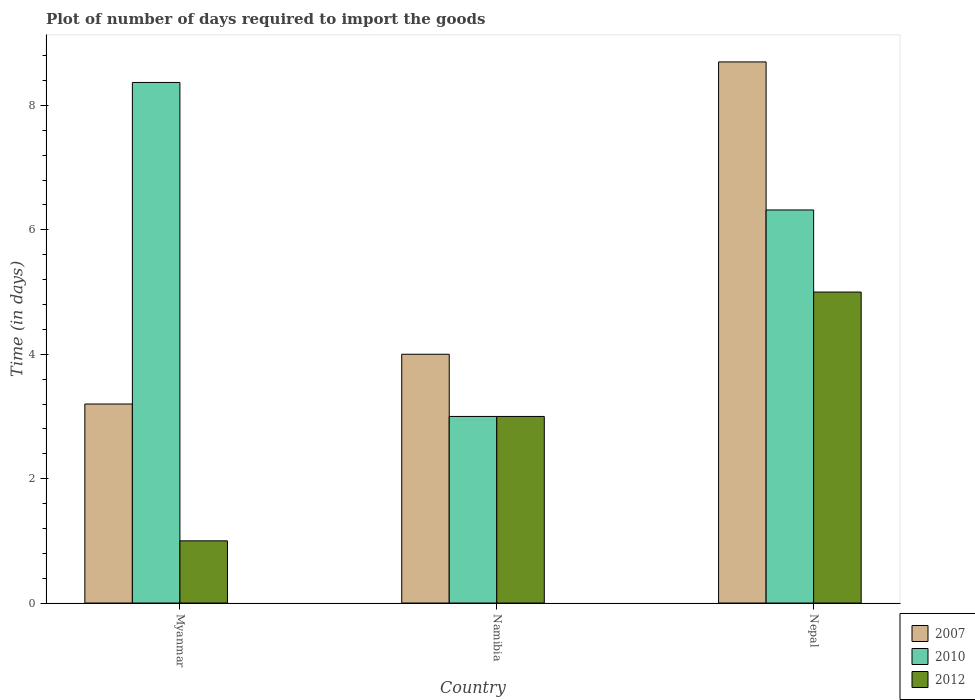How many groups of bars are there?
Offer a terse response. 3. Are the number of bars per tick equal to the number of legend labels?
Provide a succinct answer. Yes. How many bars are there on the 2nd tick from the left?
Make the answer very short. 3. How many bars are there on the 2nd tick from the right?
Give a very brief answer. 3. What is the label of the 3rd group of bars from the left?
Keep it short and to the point. Nepal. In how many cases, is the number of bars for a given country not equal to the number of legend labels?
Give a very brief answer. 0. Across all countries, what is the maximum time required to import goods in 2012?
Keep it short and to the point. 5. In which country was the time required to import goods in 2007 maximum?
Keep it short and to the point. Nepal. In which country was the time required to import goods in 2012 minimum?
Keep it short and to the point. Myanmar. What is the total time required to import goods in 2007 in the graph?
Make the answer very short. 15.9. What is the difference between the time required to import goods in 2010 in Myanmar and that in Namibia?
Keep it short and to the point. 5.37. What is the difference between the time required to import goods in 2012 in Myanmar and the time required to import goods in 2007 in Namibia?
Offer a very short reply. -3. What is the average time required to import goods in 2012 per country?
Keep it short and to the point. 3. What is the difference between the time required to import goods of/in 2007 and time required to import goods of/in 2012 in Myanmar?
Your answer should be very brief. 2.2. What is the ratio of the time required to import goods in 2010 in Myanmar to that in Namibia?
Keep it short and to the point. 2.79. What is the difference between the highest and the second highest time required to import goods in 2012?
Provide a short and direct response. -2. What is the difference between the highest and the lowest time required to import goods in 2010?
Offer a very short reply. 5.37. What does the 3rd bar from the right in Myanmar represents?
Offer a terse response. 2007. Is it the case that in every country, the sum of the time required to import goods in 2007 and time required to import goods in 2012 is greater than the time required to import goods in 2010?
Your response must be concise. No. Are all the bars in the graph horizontal?
Provide a succinct answer. No. Does the graph contain grids?
Your answer should be very brief. No. Where does the legend appear in the graph?
Your response must be concise. Bottom right. What is the title of the graph?
Your answer should be very brief. Plot of number of days required to import the goods. What is the label or title of the Y-axis?
Ensure brevity in your answer.  Time (in days). What is the Time (in days) in 2010 in Myanmar?
Give a very brief answer. 8.37. What is the Time (in days) in 2012 in Myanmar?
Provide a succinct answer. 1. What is the Time (in days) in 2012 in Namibia?
Your answer should be very brief. 3. What is the Time (in days) in 2007 in Nepal?
Your response must be concise. 8.7. What is the Time (in days) of 2010 in Nepal?
Your response must be concise. 6.32. What is the Time (in days) in 2012 in Nepal?
Keep it short and to the point. 5. Across all countries, what is the maximum Time (in days) of 2007?
Offer a very short reply. 8.7. Across all countries, what is the maximum Time (in days) of 2010?
Your answer should be very brief. 8.37. Across all countries, what is the minimum Time (in days) of 2007?
Ensure brevity in your answer.  3.2. What is the total Time (in days) of 2007 in the graph?
Keep it short and to the point. 15.9. What is the total Time (in days) of 2010 in the graph?
Give a very brief answer. 17.69. What is the difference between the Time (in days) in 2010 in Myanmar and that in Namibia?
Make the answer very short. 5.37. What is the difference between the Time (in days) of 2012 in Myanmar and that in Namibia?
Your response must be concise. -2. What is the difference between the Time (in days) in 2010 in Myanmar and that in Nepal?
Make the answer very short. 2.05. What is the difference between the Time (in days) in 2007 in Namibia and that in Nepal?
Offer a very short reply. -4.7. What is the difference between the Time (in days) of 2010 in Namibia and that in Nepal?
Your response must be concise. -3.32. What is the difference between the Time (in days) in 2012 in Namibia and that in Nepal?
Make the answer very short. -2. What is the difference between the Time (in days) in 2007 in Myanmar and the Time (in days) in 2012 in Namibia?
Make the answer very short. 0.2. What is the difference between the Time (in days) in 2010 in Myanmar and the Time (in days) in 2012 in Namibia?
Your answer should be very brief. 5.37. What is the difference between the Time (in days) of 2007 in Myanmar and the Time (in days) of 2010 in Nepal?
Offer a very short reply. -3.12. What is the difference between the Time (in days) of 2010 in Myanmar and the Time (in days) of 2012 in Nepal?
Your answer should be very brief. 3.37. What is the difference between the Time (in days) of 2007 in Namibia and the Time (in days) of 2010 in Nepal?
Your response must be concise. -2.32. What is the difference between the Time (in days) in 2007 in Namibia and the Time (in days) in 2012 in Nepal?
Your answer should be very brief. -1. What is the average Time (in days) of 2007 per country?
Ensure brevity in your answer.  5.3. What is the average Time (in days) of 2010 per country?
Provide a short and direct response. 5.9. What is the difference between the Time (in days) of 2007 and Time (in days) of 2010 in Myanmar?
Your answer should be very brief. -5.17. What is the difference between the Time (in days) of 2010 and Time (in days) of 2012 in Myanmar?
Make the answer very short. 7.37. What is the difference between the Time (in days) in 2007 and Time (in days) in 2010 in Namibia?
Offer a terse response. 1. What is the difference between the Time (in days) of 2007 and Time (in days) of 2010 in Nepal?
Offer a terse response. 2.38. What is the difference between the Time (in days) in 2007 and Time (in days) in 2012 in Nepal?
Provide a short and direct response. 3.7. What is the difference between the Time (in days) of 2010 and Time (in days) of 2012 in Nepal?
Make the answer very short. 1.32. What is the ratio of the Time (in days) of 2007 in Myanmar to that in Namibia?
Make the answer very short. 0.8. What is the ratio of the Time (in days) of 2010 in Myanmar to that in Namibia?
Offer a very short reply. 2.79. What is the ratio of the Time (in days) in 2007 in Myanmar to that in Nepal?
Make the answer very short. 0.37. What is the ratio of the Time (in days) of 2010 in Myanmar to that in Nepal?
Ensure brevity in your answer.  1.32. What is the ratio of the Time (in days) of 2012 in Myanmar to that in Nepal?
Your answer should be very brief. 0.2. What is the ratio of the Time (in days) in 2007 in Namibia to that in Nepal?
Offer a terse response. 0.46. What is the ratio of the Time (in days) of 2010 in Namibia to that in Nepal?
Your answer should be compact. 0.47. What is the difference between the highest and the second highest Time (in days) in 2007?
Provide a succinct answer. 4.7. What is the difference between the highest and the second highest Time (in days) in 2010?
Offer a very short reply. 2.05. What is the difference between the highest and the lowest Time (in days) of 2007?
Keep it short and to the point. 5.5. What is the difference between the highest and the lowest Time (in days) of 2010?
Ensure brevity in your answer.  5.37. What is the difference between the highest and the lowest Time (in days) of 2012?
Make the answer very short. 4. 